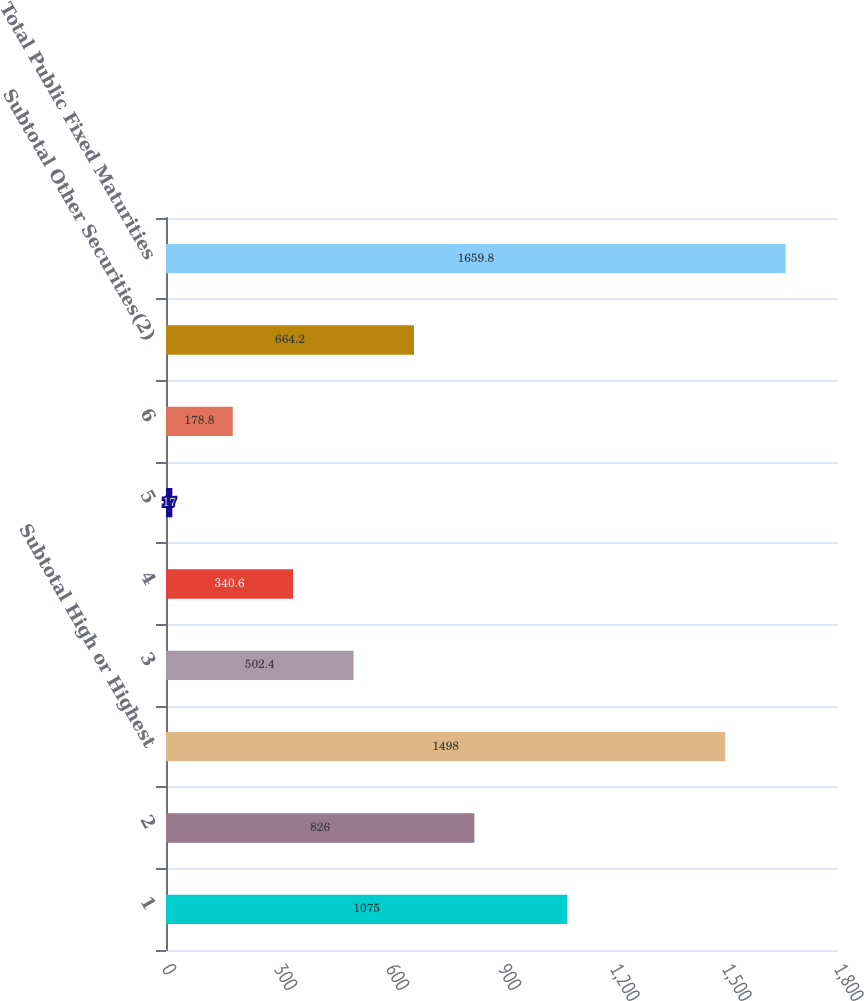<chart> <loc_0><loc_0><loc_500><loc_500><bar_chart><fcel>1<fcel>2<fcel>Subtotal High or Highest<fcel>3<fcel>4<fcel>5<fcel>6<fcel>Subtotal Other Securities(2)<fcel>Total Public Fixed Maturities<nl><fcel>1075<fcel>826<fcel>1498<fcel>502.4<fcel>340.6<fcel>17<fcel>178.8<fcel>664.2<fcel>1659.8<nl></chart> 